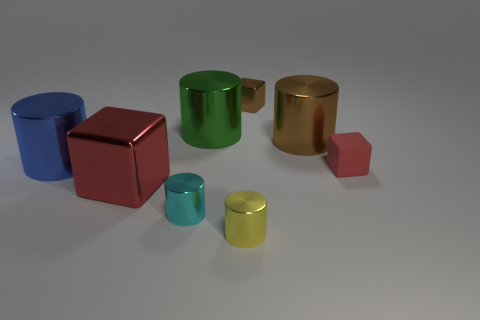Subtract all green cubes. Subtract all purple cylinders. How many cubes are left? 3 Subtract all green cylinders. How many blue blocks are left? 0 Add 5 small browns. How many greens exist? 0 Subtract all tiny purple rubber cubes. Subtract all small yellow cylinders. How many objects are left? 7 Add 3 cyan metal objects. How many cyan metal objects are left? 4 Add 3 large yellow objects. How many large yellow objects exist? 3 Add 1 red matte things. How many objects exist? 9 Subtract all yellow cylinders. How many cylinders are left? 4 Subtract all yellow cylinders. How many cylinders are left? 4 Subtract 0 green blocks. How many objects are left? 8 